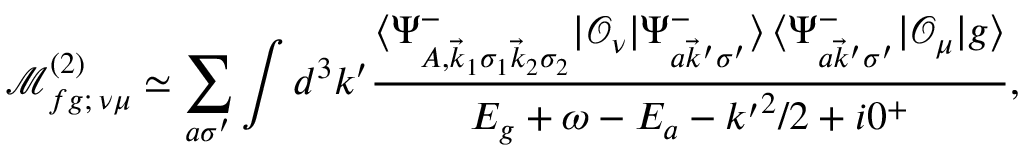Convert formula to latex. <formula><loc_0><loc_0><loc_500><loc_500>\mathcal { M } _ { f g ; \, \nu \mu } ^ { ( 2 ) } \simeq \sum _ { a \sigma ^ { \prime } } \int d ^ { 3 } k ^ { \prime } \frac { \langle \Psi _ { A , \vec { k } _ { 1 } \sigma _ { 1 } \vec { k } _ { 2 } \sigma _ { 2 } } ^ { - } | \mathcal { O } _ { \nu } | \Psi _ { a \vec { k } ^ { \prime } \sigma ^ { \prime } } ^ { - } \rangle \, \langle \Psi _ { a \vec { k } ^ { \prime } \sigma ^ { \prime } } ^ { - } | \mathcal { O } _ { \mu } | g \rangle } { E _ { g } + \omega - E _ { a } - { k ^ { \prime } } ^ { 2 } / 2 + i 0 ^ { + } } ,</formula> 